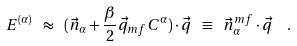Convert formula to latex. <formula><loc_0><loc_0><loc_500><loc_500>E ^ { ( \alpha ) } \ \approx \ ( \vec { n } _ { \alpha } + \frac { \beta } { 2 } \vec { q } _ { m f } C ^ { \alpha } ) \cdot \vec { q } \ \equiv \ \vec { n } _ { \alpha } ^ { m f } \cdot \vec { q } \ \ .</formula> 